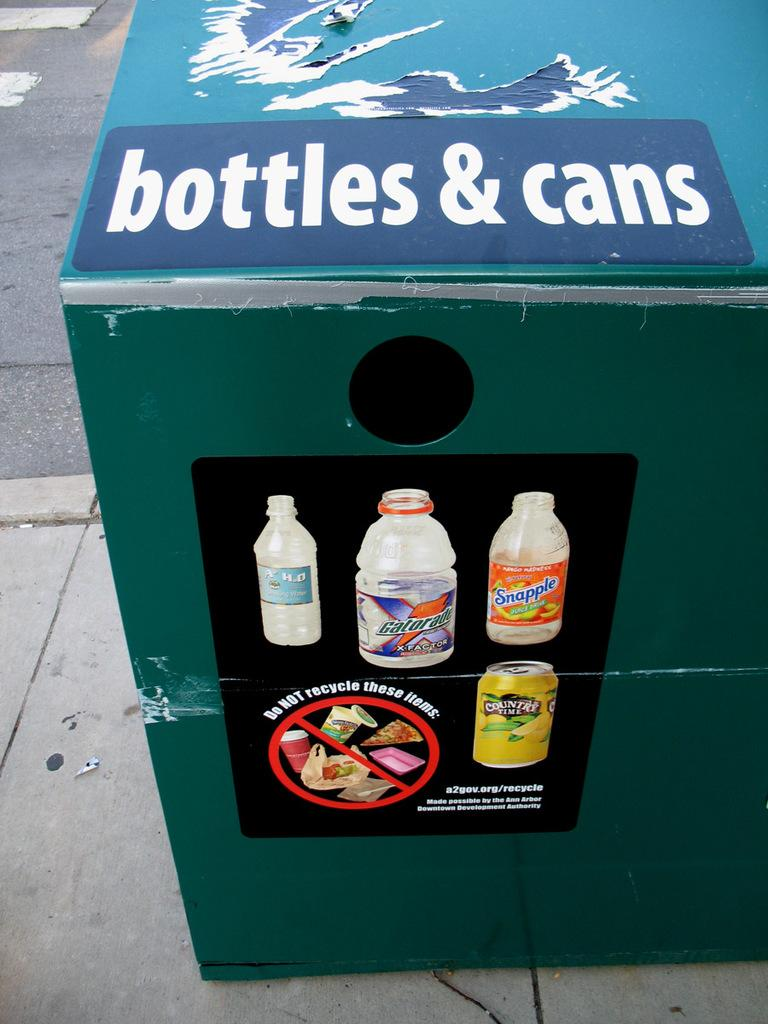<image>
Write a terse but informative summary of the picture. a large bin that is labeled 'bottle & cans' at the top 